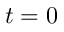Convert formula to latex. <formula><loc_0><loc_0><loc_500><loc_500>t = 0</formula> 